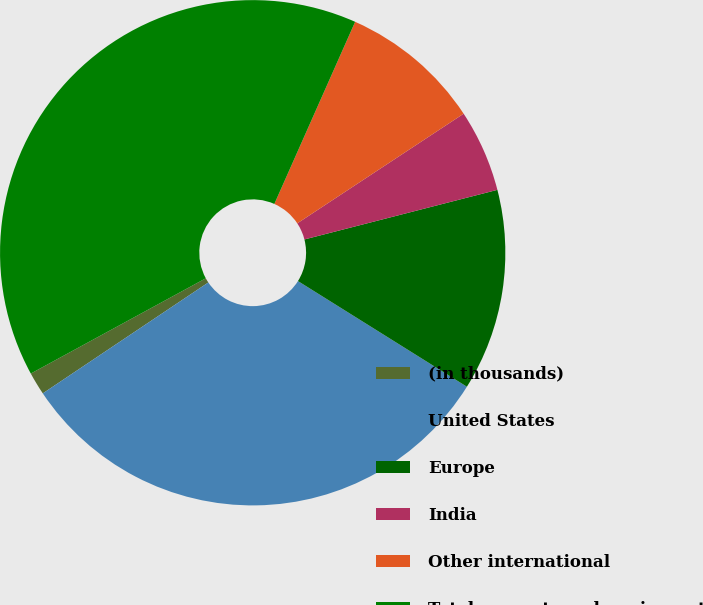Convert chart. <chart><loc_0><loc_0><loc_500><loc_500><pie_chart><fcel>(in thousands)<fcel>United States<fcel>Europe<fcel>India<fcel>Other international<fcel>Total property and equipment<nl><fcel>1.46%<fcel>31.71%<fcel>12.9%<fcel>5.27%<fcel>9.08%<fcel>39.58%<nl></chart> 